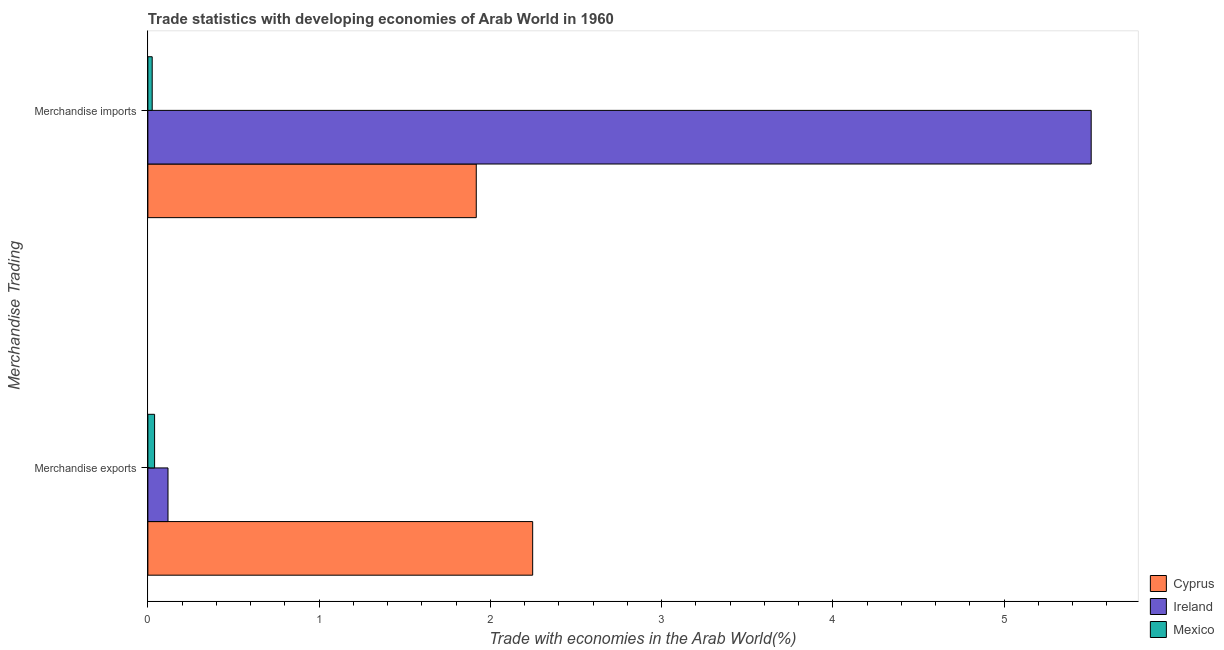How many different coloured bars are there?
Give a very brief answer. 3. Are the number of bars per tick equal to the number of legend labels?
Your answer should be compact. Yes. Are the number of bars on each tick of the Y-axis equal?
Keep it short and to the point. Yes. How many bars are there on the 1st tick from the top?
Your response must be concise. 3. What is the merchandise imports in Cyprus?
Give a very brief answer. 1.92. Across all countries, what is the maximum merchandise exports?
Make the answer very short. 2.25. Across all countries, what is the minimum merchandise exports?
Offer a very short reply. 0.04. In which country was the merchandise imports maximum?
Your answer should be compact. Ireland. What is the total merchandise imports in the graph?
Offer a very short reply. 7.45. What is the difference between the merchandise imports in Cyprus and that in Mexico?
Your answer should be compact. 1.89. What is the difference between the merchandise exports in Mexico and the merchandise imports in Ireland?
Offer a very short reply. -5.47. What is the average merchandise imports per country?
Give a very brief answer. 2.48. What is the difference between the merchandise imports and merchandise exports in Mexico?
Provide a succinct answer. -0.01. In how many countries, is the merchandise exports greater than 0.6000000000000001 %?
Give a very brief answer. 1. What is the ratio of the merchandise exports in Cyprus to that in Mexico?
Provide a short and direct response. 57.26. Is the merchandise exports in Cyprus less than that in Mexico?
Your answer should be compact. No. What does the 1st bar from the top in Merchandise exports represents?
Give a very brief answer. Mexico. What does the 1st bar from the bottom in Merchandise imports represents?
Keep it short and to the point. Cyprus. How many countries are there in the graph?
Offer a very short reply. 3. How many legend labels are there?
Keep it short and to the point. 3. How are the legend labels stacked?
Keep it short and to the point. Vertical. What is the title of the graph?
Your answer should be compact. Trade statistics with developing economies of Arab World in 1960. What is the label or title of the X-axis?
Your response must be concise. Trade with economies in the Arab World(%). What is the label or title of the Y-axis?
Your answer should be very brief. Merchandise Trading. What is the Trade with economies in the Arab World(%) in Cyprus in Merchandise exports?
Your response must be concise. 2.25. What is the Trade with economies in the Arab World(%) in Ireland in Merchandise exports?
Make the answer very short. 0.12. What is the Trade with economies in the Arab World(%) in Mexico in Merchandise exports?
Provide a succinct answer. 0.04. What is the Trade with economies in the Arab World(%) of Cyprus in Merchandise imports?
Your response must be concise. 1.92. What is the Trade with economies in the Arab World(%) in Ireland in Merchandise imports?
Give a very brief answer. 5.51. What is the Trade with economies in the Arab World(%) in Mexico in Merchandise imports?
Ensure brevity in your answer.  0.03. Across all Merchandise Trading, what is the maximum Trade with economies in the Arab World(%) of Cyprus?
Offer a very short reply. 2.25. Across all Merchandise Trading, what is the maximum Trade with economies in the Arab World(%) in Ireland?
Your answer should be compact. 5.51. Across all Merchandise Trading, what is the maximum Trade with economies in the Arab World(%) in Mexico?
Provide a short and direct response. 0.04. Across all Merchandise Trading, what is the minimum Trade with economies in the Arab World(%) in Cyprus?
Your response must be concise. 1.92. Across all Merchandise Trading, what is the minimum Trade with economies in the Arab World(%) of Ireland?
Offer a very short reply. 0.12. Across all Merchandise Trading, what is the minimum Trade with economies in the Arab World(%) of Mexico?
Provide a succinct answer. 0.03. What is the total Trade with economies in the Arab World(%) of Cyprus in the graph?
Offer a very short reply. 4.17. What is the total Trade with economies in the Arab World(%) in Ireland in the graph?
Offer a terse response. 5.63. What is the total Trade with economies in the Arab World(%) in Mexico in the graph?
Provide a short and direct response. 0.06. What is the difference between the Trade with economies in the Arab World(%) in Cyprus in Merchandise exports and that in Merchandise imports?
Your response must be concise. 0.33. What is the difference between the Trade with economies in the Arab World(%) of Ireland in Merchandise exports and that in Merchandise imports?
Offer a very short reply. -5.39. What is the difference between the Trade with economies in the Arab World(%) in Mexico in Merchandise exports and that in Merchandise imports?
Ensure brevity in your answer.  0.01. What is the difference between the Trade with economies in the Arab World(%) of Cyprus in Merchandise exports and the Trade with economies in the Arab World(%) of Ireland in Merchandise imports?
Keep it short and to the point. -3.26. What is the difference between the Trade with economies in the Arab World(%) in Cyprus in Merchandise exports and the Trade with economies in the Arab World(%) in Mexico in Merchandise imports?
Offer a terse response. 2.22. What is the difference between the Trade with economies in the Arab World(%) in Ireland in Merchandise exports and the Trade with economies in the Arab World(%) in Mexico in Merchandise imports?
Your answer should be very brief. 0.09. What is the average Trade with economies in the Arab World(%) in Cyprus per Merchandise Trading?
Make the answer very short. 2.08. What is the average Trade with economies in the Arab World(%) in Ireland per Merchandise Trading?
Provide a succinct answer. 2.81. What is the average Trade with economies in the Arab World(%) in Mexico per Merchandise Trading?
Ensure brevity in your answer.  0.03. What is the difference between the Trade with economies in the Arab World(%) in Cyprus and Trade with economies in the Arab World(%) in Ireland in Merchandise exports?
Your answer should be compact. 2.13. What is the difference between the Trade with economies in the Arab World(%) in Cyprus and Trade with economies in the Arab World(%) in Mexico in Merchandise exports?
Make the answer very short. 2.21. What is the difference between the Trade with economies in the Arab World(%) in Ireland and Trade with economies in the Arab World(%) in Mexico in Merchandise exports?
Offer a terse response. 0.08. What is the difference between the Trade with economies in the Arab World(%) in Cyprus and Trade with economies in the Arab World(%) in Ireland in Merchandise imports?
Give a very brief answer. -3.59. What is the difference between the Trade with economies in the Arab World(%) in Cyprus and Trade with economies in the Arab World(%) in Mexico in Merchandise imports?
Your response must be concise. 1.89. What is the difference between the Trade with economies in the Arab World(%) of Ireland and Trade with economies in the Arab World(%) of Mexico in Merchandise imports?
Give a very brief answer. 5.48. What is the ratio of the Trade with economies in the Arab World(%) in Cyprus in Merchandise exports to that in Merchandise imports?
Keep it short and to the point. 1.17. What is the ratio of the Trade with economies in the Arab World(%) in Ireland in Merchandise exports to that in Merchandise imports?
Make the answer very short. 0.02. What is the ratio of the Trade with economies in the Arab World(%) in Mexico in Merchandise exports to that in Merchandise imports?
Your answer should be compact. 1.55. What is the difference between the highest and the second highest Trade with economies in the Arab World(%) in Cyprus?
Provide a short and direct response. 0.33. What is the difference between the highest and the second highest Trade with economies in the Arab World(%) in Ireland?
Provide a short and direct response. 5.39. What is the difference between the highest and the second highest Trade with economies in the Arab World(%) in Mexico?
Give a very brief answer. 0.01. What is the difference between the highest and the lowest Trade with economies in the Arab World(%) in Cyprus?
Keep it short and to the point. 0.33. What is the difference between the highest and the lowest Trade with economies in the Arab World(%) of Ireland?
Ensure brevity in your answer.  5.39. What is the difference between the highest and the lowest Trade with economies in the Arab World(%) of Mexico?
Give a very brief answer. 0.01. 